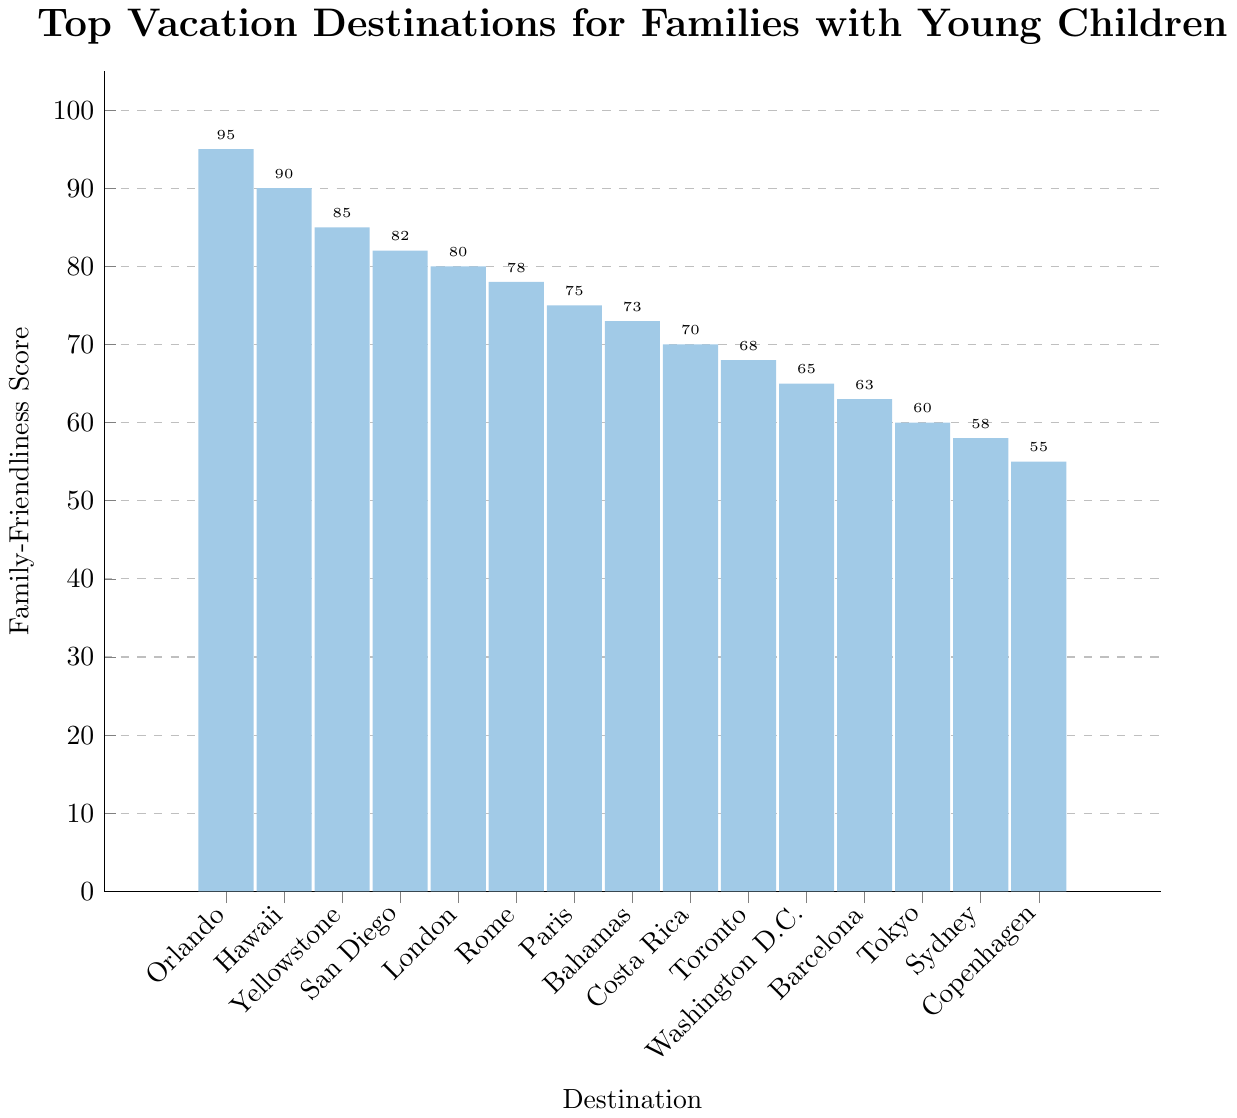Which vacation destination has the highest family-friendliness score? The bar for Orlando reaches the highest on the y-axis, indicating it has the highest family-friendliness score.
Answer: Orlando (Disney World) Which three destinations have the lowest family-friendliness scores? The three shortest bars are for Copenhagen, Sydney, and Tokyo, making these the destinations with the lowest family-friendliness scores.
Answer: Copenhagen, Sydney, Tokyo What is the difference in family-friendliness scores between Orlando (Disney World) and Copenhagen? Orlando (Disney World) has a score of 95, while Copenhagen has a score of 55. The difference is 95 - 55 = 40.
Answer: 40 Which destination scored exactly 75 on the family-friendliness scale? The bar for Paris reaches up to the 75 mark on the y-axis, indicating it scored exactly 75 on the family-friendliness scale.
Answer: Paris How many destinations have a family-friendliness score above 80? The bars for Orlando, Beach Resort in Hawaii, Yellowstone National Park, and San Diego all reach above the 80 mark on the y-axis. This means 4 destinations have scores above 80.
Answer: 4 Which destination is slightly more family-friendly, Rome or London? London's bar reaches the 80 mark, while Rome's bar is slightly lower at 78. Therefore, London is slightly more family-friendly.
Answer: London What is the combined family-friendliness score of the top three destinations? The scores for the top three destinations are Orlando (95), Beach Resort in Hawaii (90), and Yellowstone National Park (85). Adding these scores gives 95 + 90 + 85 = 270.
Answer: 270 Which destination has a lower family-friendliness score, Bahamas or Costa Rica? The bar for Costa Rica is lower than the bar for Bahamas. Costa Rica has a family-friendliness score of 70, while Bahamas has a score of 73.
Answer: Costa Rica How much higher is the family-friendliness score of San Diego compared to Washington D.C.? San Diego has a score of 82, and Washington D.C. has a score of 65. The difference is 82 - 65 = 17.
Answer: 17 Which has a larger score difference, between London and Tokyo or between Sydney and Barcelona? London scores 80 and Tokyo scores 60, resulting in a difference of 80 - 60 = 20. Sydney scores 58 and Barcelona scores 63, resulting in a difference of 63 - 58 = 5. The difference between London and Tokyo is larger.
Answer: London and Tokyo 